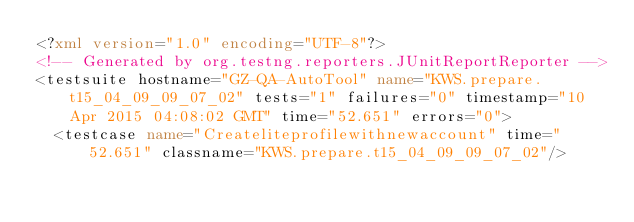Convert code to text. <code><loc_0><loc_0><loc_500><loc_500><_XML_><?xml version="1.0" encoding="UTF-8"?>
<!-- Generated by org.testng.reporters.JUnitReportReporter -->
<testsuite hostname="GZ-QA-AutoTool" name="KWS.prepare.t15_04_09_09_07_02" tests="1" failures="0" timestamp="10 Apr 2015 04:08:02 GMT" time="52.651" errors="0">
  <testcase name="Createliteprofilewithnewaccount" time="52.651" classname="KWS.prepare.t15_04_09_09_07_02"/></code> 